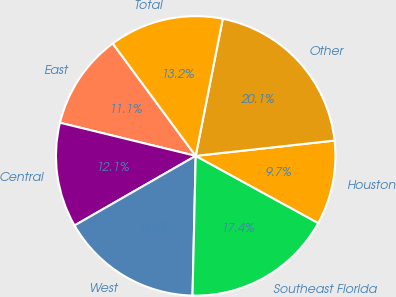Convert chart. <chart><loc_0><loc_0><loc_500><loc_500><pie_chart><fcel>East<fcel>Central<fcel>West<fcel>Southeast Florida<fcel>Houston<fcel>Other<fcel>Total<nl><fcel>11.07%<fcel>12.11%<fcel>16.34%<fcel>17.38%<fcel>9.73%<fcel>20.15%<fcel>13.22%<nl></chart> 